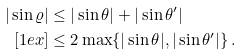Convert formula to latex. <formula><loc_0><loc_0><loc_500><loc_500>| \sin \varrho | & \leq | \sin \theta | + | \sin \theta ^ { \prime } | \\ [ 1 e x ] & \leq 2 \max \{ | \sin \theta | , | \sin \theta ^ { \prime } | \} \, .</formula> 